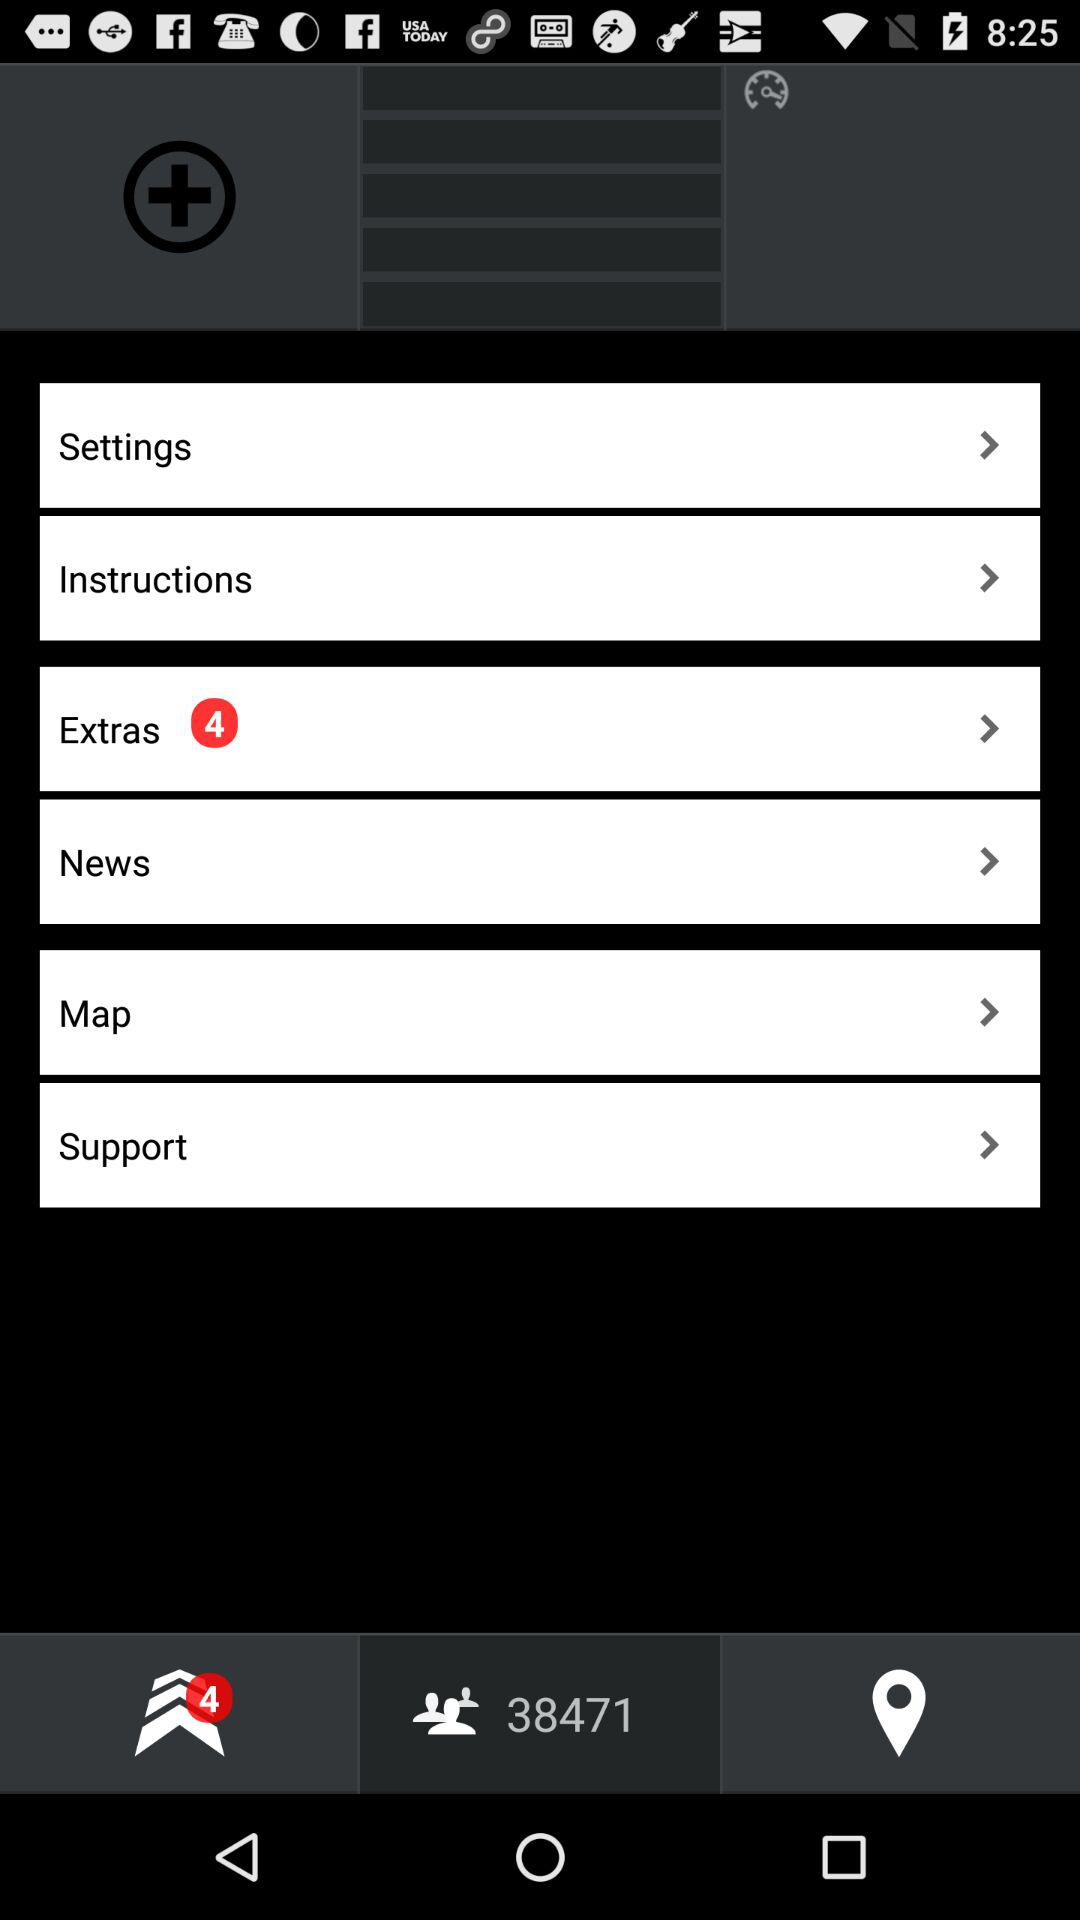How many pending notifications are in "Extras"? There are 4 pending notifications. 